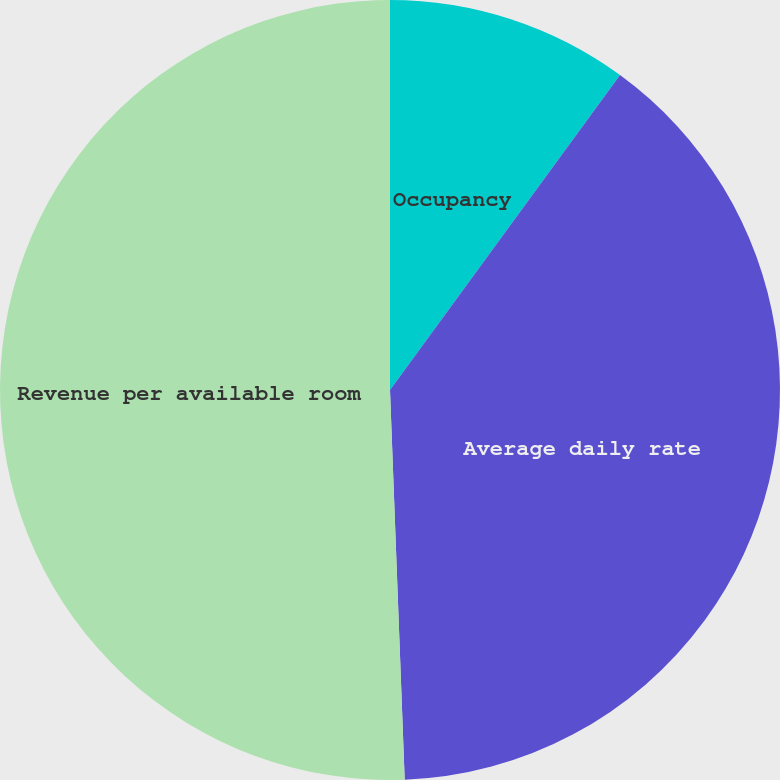<chart> <loc_0><loc_0><loc_500><loc_500><pie_chart><fcel>Occupancy<fcel>Average daily rate<fcel>Revenue per available room<nl><fcel>10.04%<fcel>39.36%<fcel>50.6%<nl></chart> 